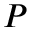<formula> <loc_0><loc_0><loc_500><loc_500>P</formula> 